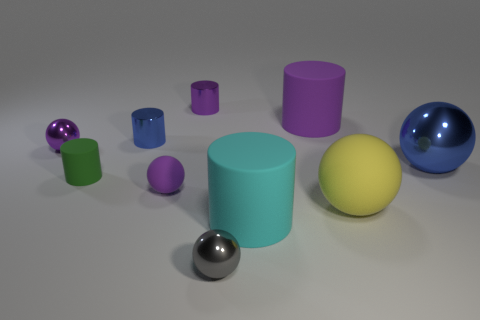There is another big metallic object that is the same shape as the gray metallic thing; what is its color?
Your answer should be very brief. Blue. Do the purple cylinder in front of the purple metal cylinder and the large yellow matte thing have the same size?
Give a very brief answer. Yes. How many other things are the same size as the gray shiny object?
Offer a terse response. 5. What is the color of the big rubber ball?
Offer a terse response. Yellow. What is the tiny purple thing in front of the green matte cylinder made of?
Your answer should be very brief. Rubber. Is the number of big yellow balls that are to the left of the large purple cylinder the same as the number of tiny red objects?
Provide a succinct answer. Yes. Does the green object have the same shape as the gray metal thing?
Provide a succinct answer. No. Is there anything else that has the same color as the small matte cylinder?
Your answer should be very brief. No. What is the shape of the thing that is right of the cyan rubber cylinder and behind the big metallic sphere?
Ensure brevity in your answer.  Cylinder. Are there an equal number of tiny purple things that are in front of the small purple matte ball and blue cylinders that are on the right side of the purple rubber cylinder?
Provide a short and direct response. Yes. 